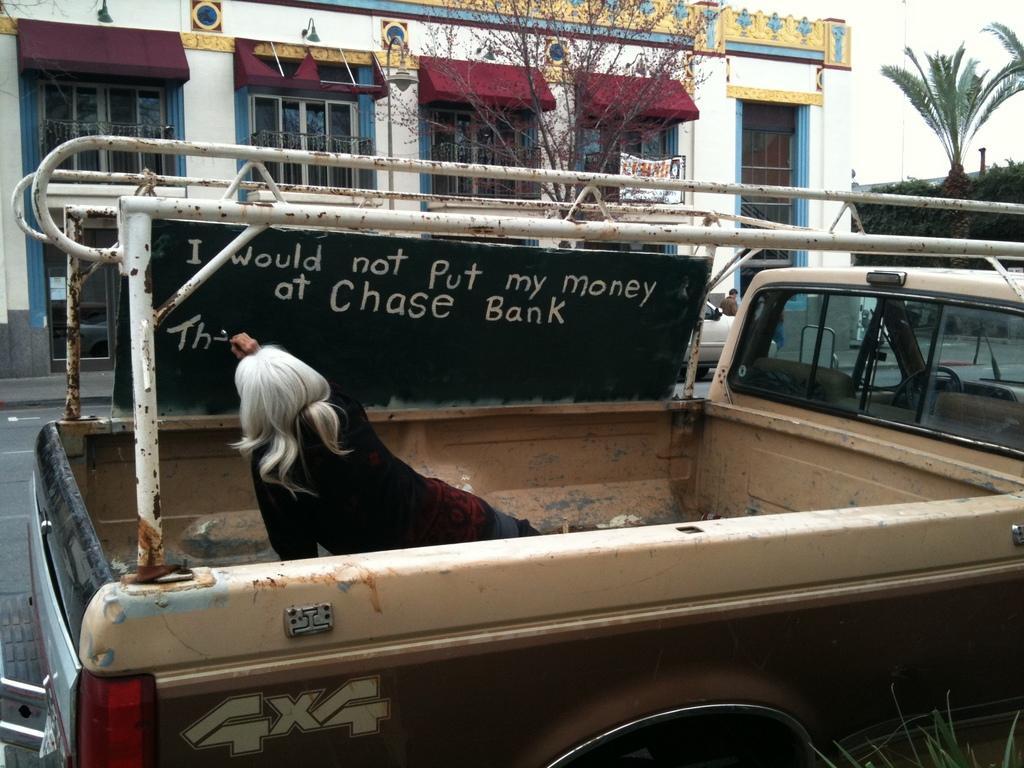How would you summarize this image in a sentence or two? There is one woman, board and a vehicle present at the bottom of this image. In the background, we can see trees and a building. 